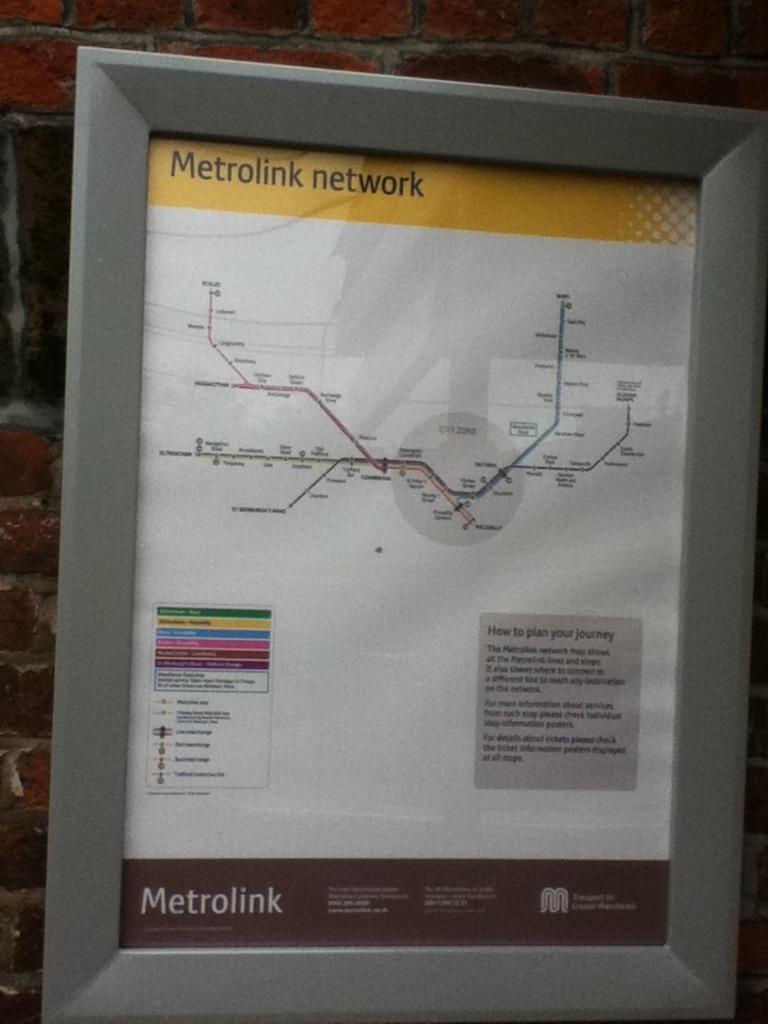What is the name of the transportation system?
Your response must be concise. Metrolink network. 